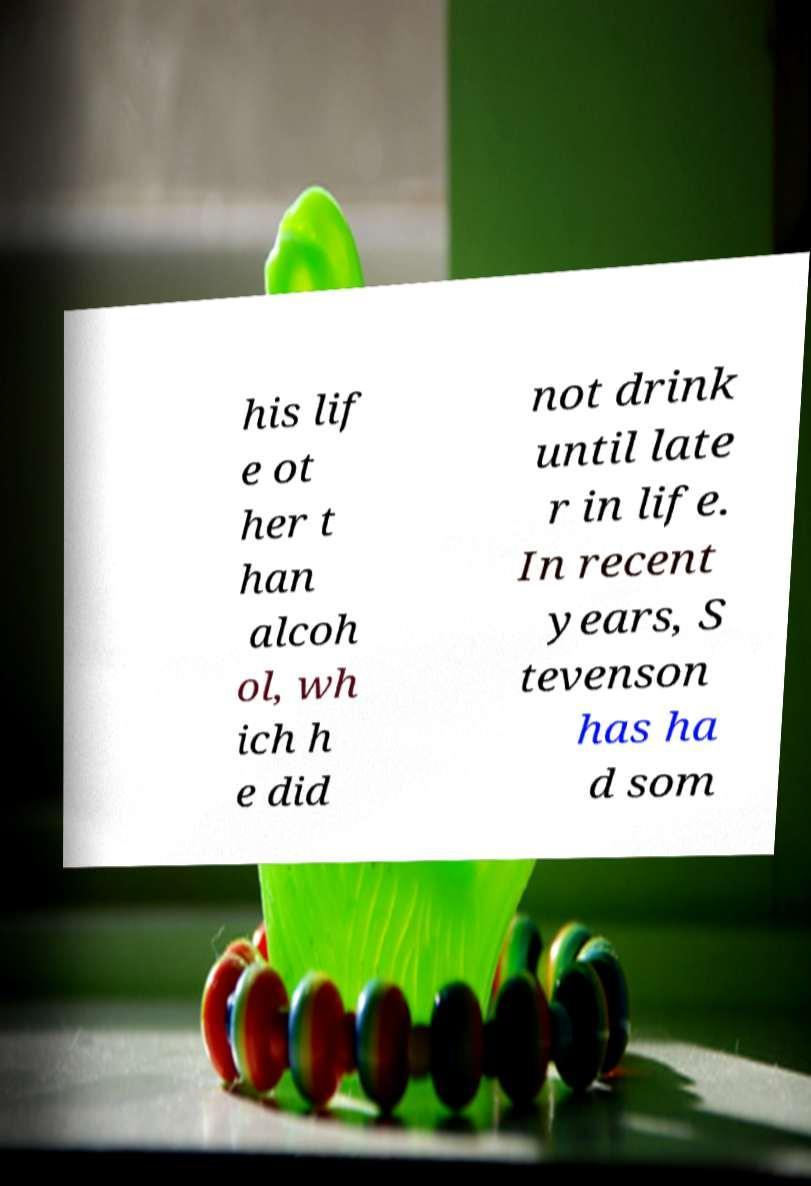I need the written content from this picture converted into text. Can you do that? his lif e ot her t han alcoh ol, wh ich h e did not drink until late r in life. In recent years, S tevenson has ha d som 